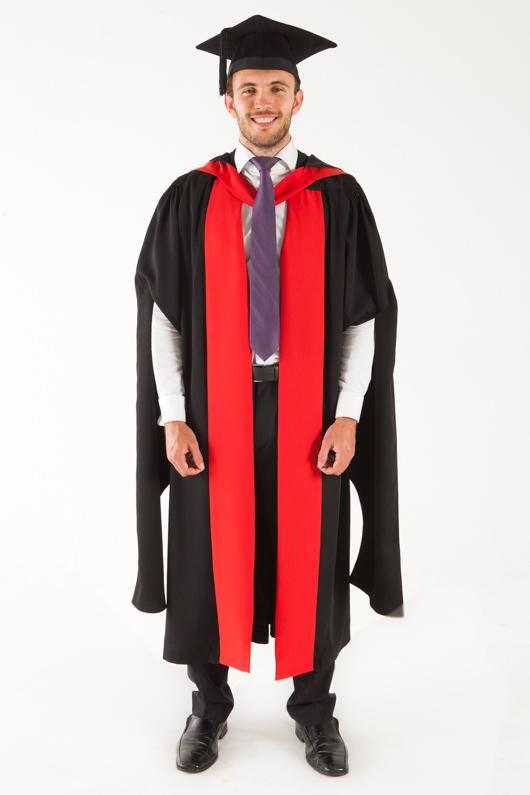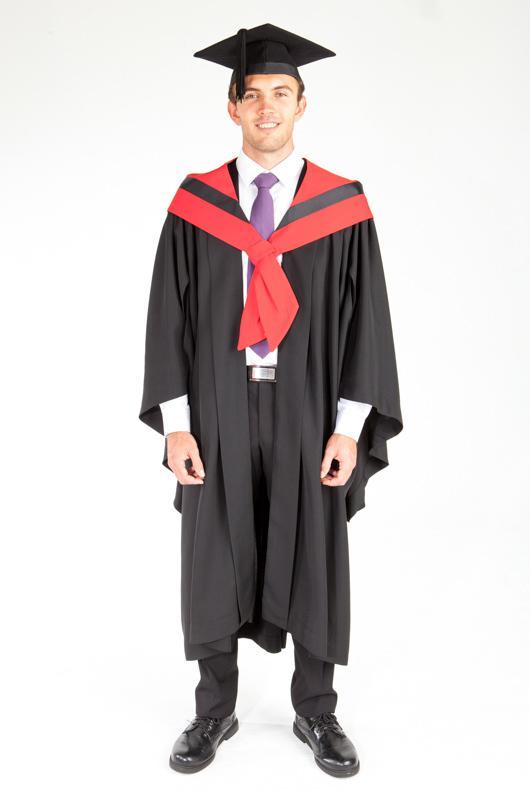The first image is the image on the left, the second image is the image on the right. For the images shown, is this caption "Both people are wearing some bright red." true? Answer yes or no. Yes. 